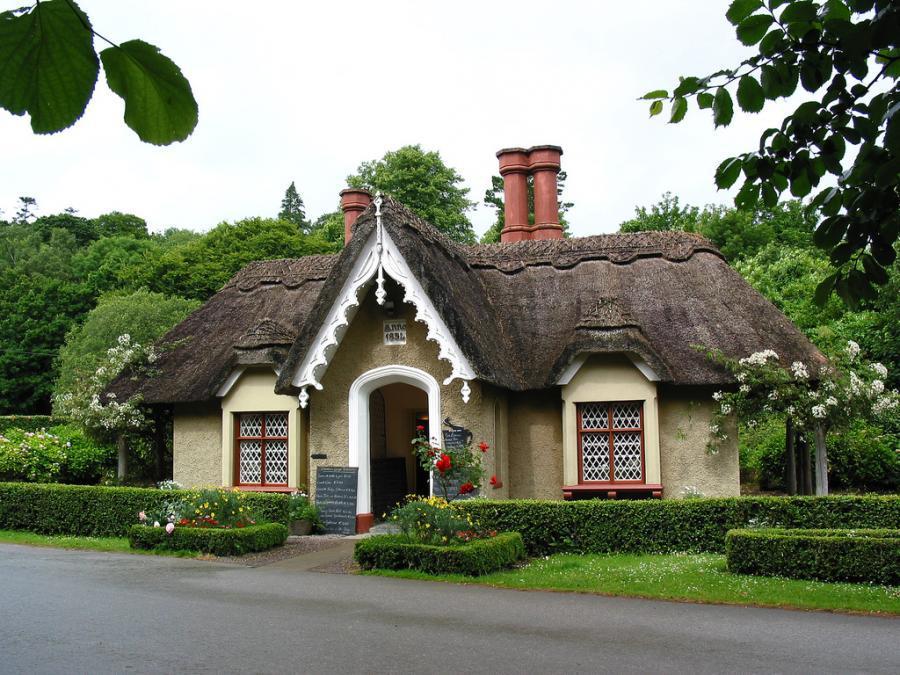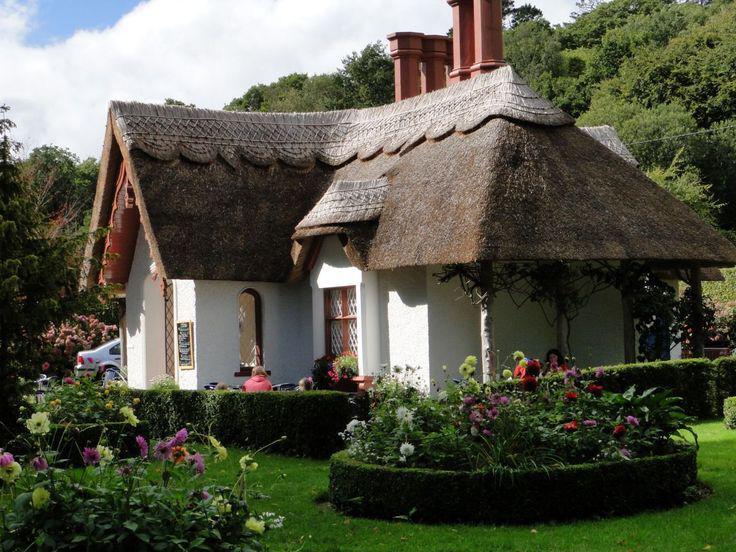The first image is the image on the left, the second image is the image on the right. Evaluate the accuracy of this statement regarding the images: "An image shows a white house with a grayish-brown roof that curves around and over a window.". Is it true? Answer yes or no. Yes. 